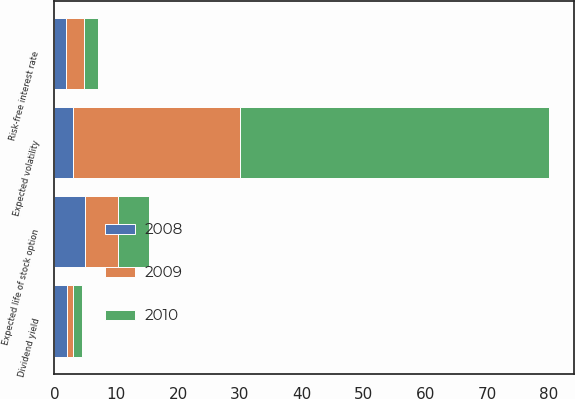Convert chart to OTSL. <chart><loc_0><loc_0><loc_500><loc_500><stacked_bar_chart><ecel><fcel>Dividend yield<fcel>Expected volatility<fcel>Risk-free interest rate<fcel>Expected life of stock option<nl><fcel>2010<fcel>1.5<fcel>50<fcel>2.3<fcel>5<nl><fcel>2008<fcel>2<fcel>3<fcel>1.8<fcel>5<nl><fcel>2009<fcel>1<fcel>27<fcel>3<fcel>5.3<nl></chart> 